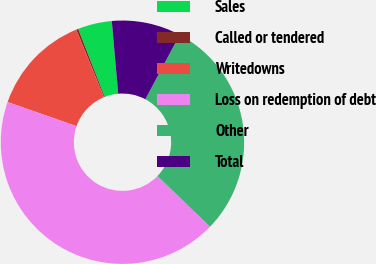Convert chart to OTSL. <chart><loc_0><loc_0><loc_500><loc_500><pie_chart><fcel>Sales<fcel>Called or tendered<fcel>Writedowns<fcel>Loss on redemption of debt<fcel>Other<fcel>Total<nl><fcel>4.53%<fcel>0.27%<fcel>13.45%<fcel>43.14%<fcel>29.43%<fcel>9.19%<nl></chart> 